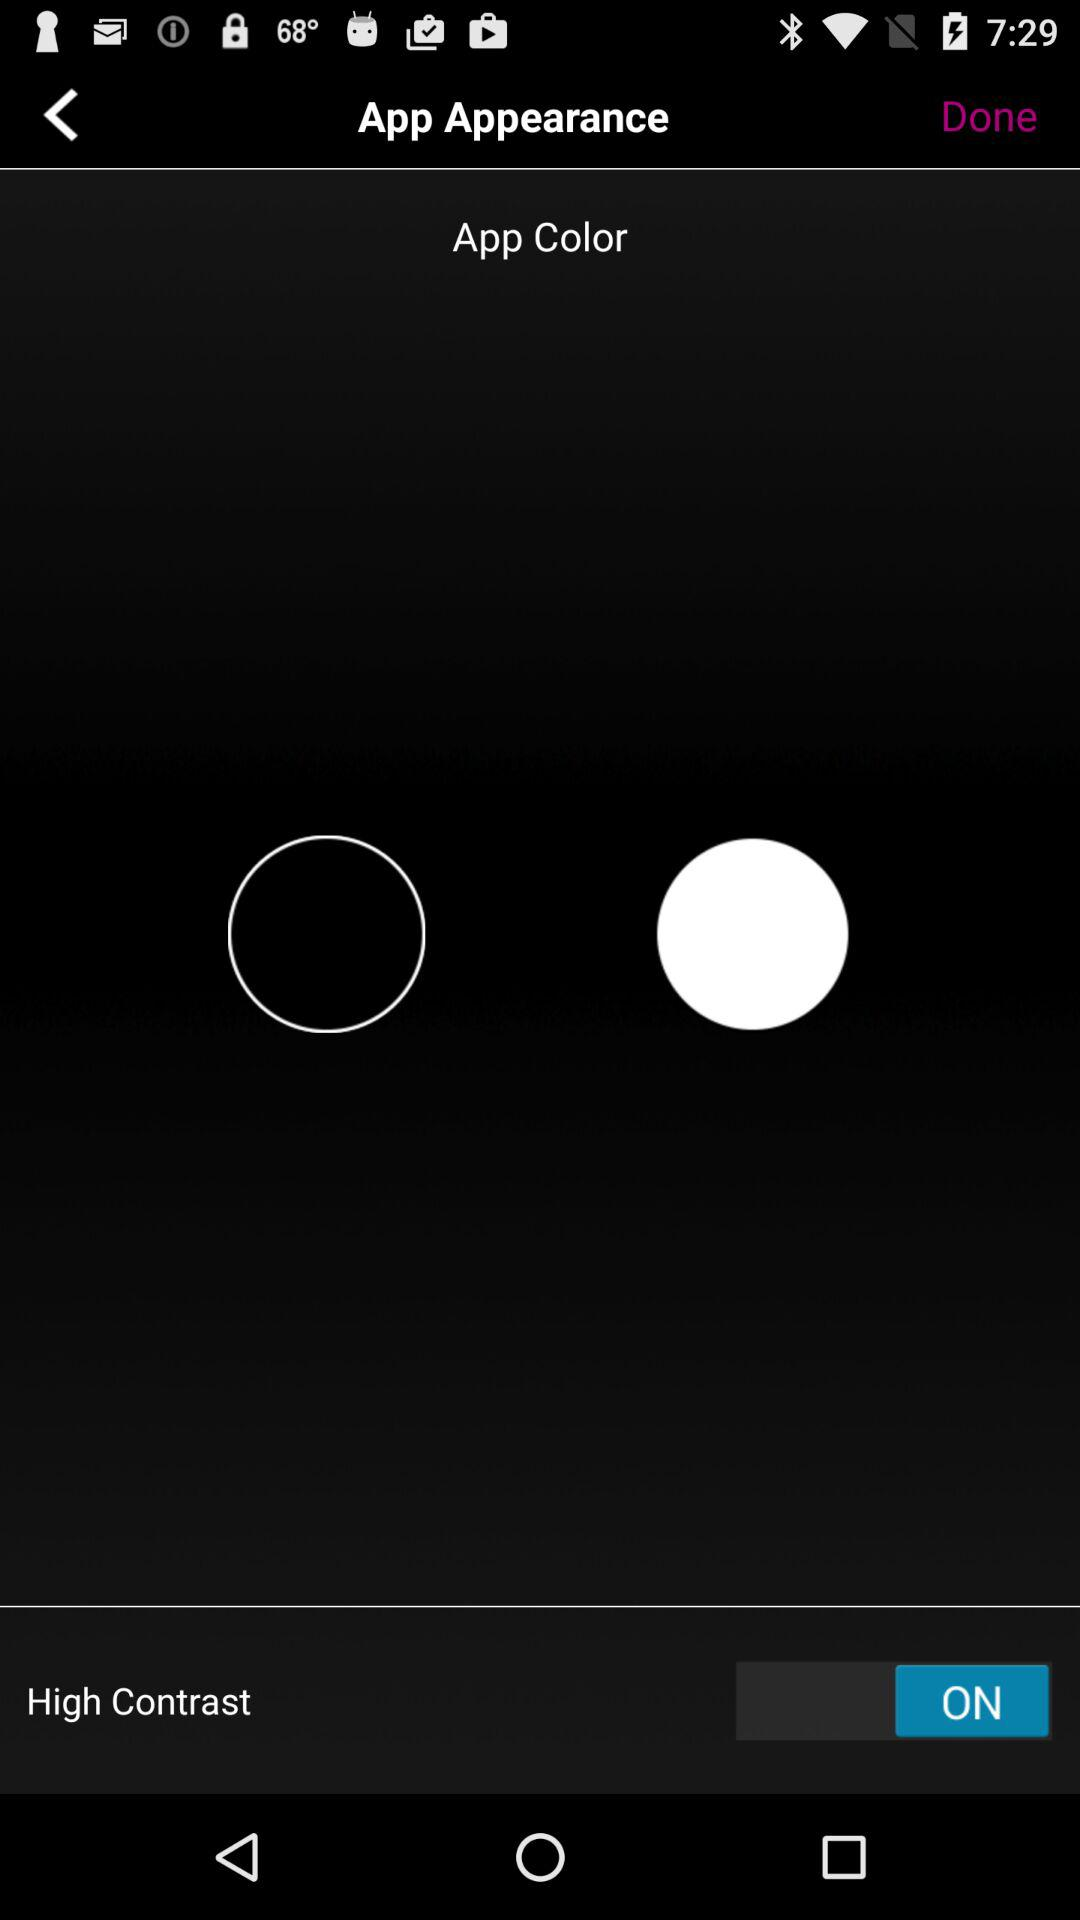What is the status of "High Contrast"? The status is "on". 